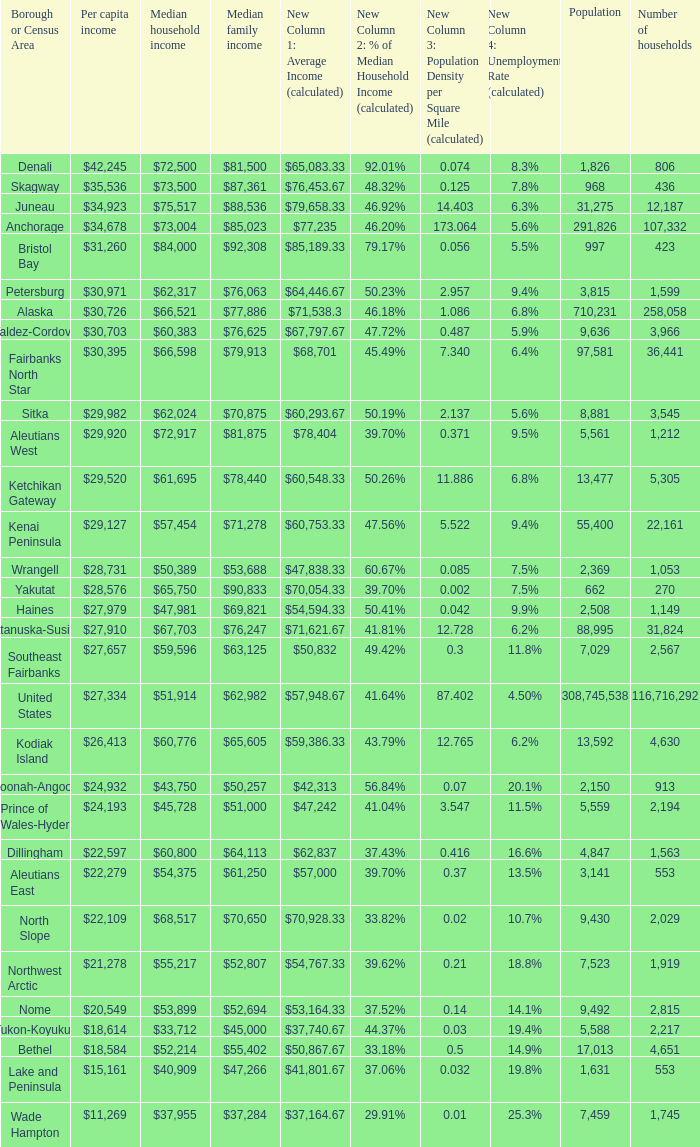Which borough or census area has a $59,596 median household income? Southeast Fairbanks. 